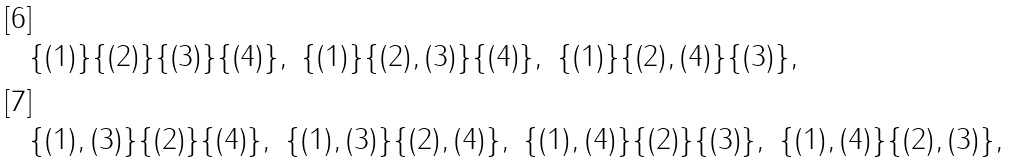<formula> <loc_0><loc_0><loc_500><loc_500>& \{ ( 1 ) \} \{ ( 2 ) \} \{ ( 3 ) \} \{ ( 4 ) \} , \ \{ ( 1 ) \} \{ ( 2 ) , ( 3 ) \} \{ ( 4 ) \} , \ \{ ( 1 ) \} \{ ( 2 ) , ( 4 ) \} \{ ( 3 ) \} , \\ & \{ ( 1 ) , ( 3 ) \} \{ ( 2 ) \} \{ ( 4 ) \} , \ \{ ( 1 ) , ( 3 ) \} \{ ( 2 ) , ( 4 ) \} , \ \{ ( 1 ) , ( 4 ) \} \{ ( 2 ) \} \{ ( 3 ) \} , \ \{ ( 1 ) , ( 4 ) \} \{ ( 2 ) , ( 3 ) \} ,</formula> 